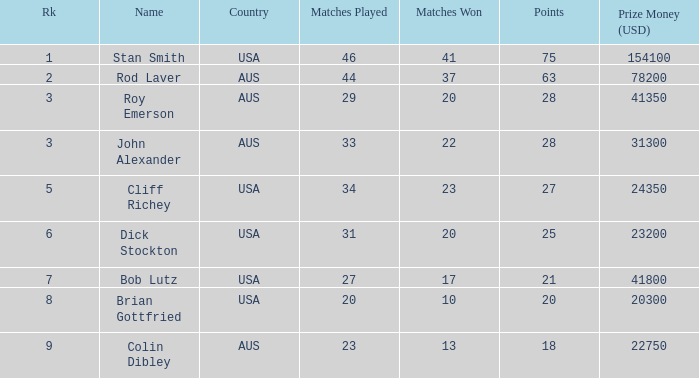How much prize money (in usd) did bob lutz win 41800.0. 